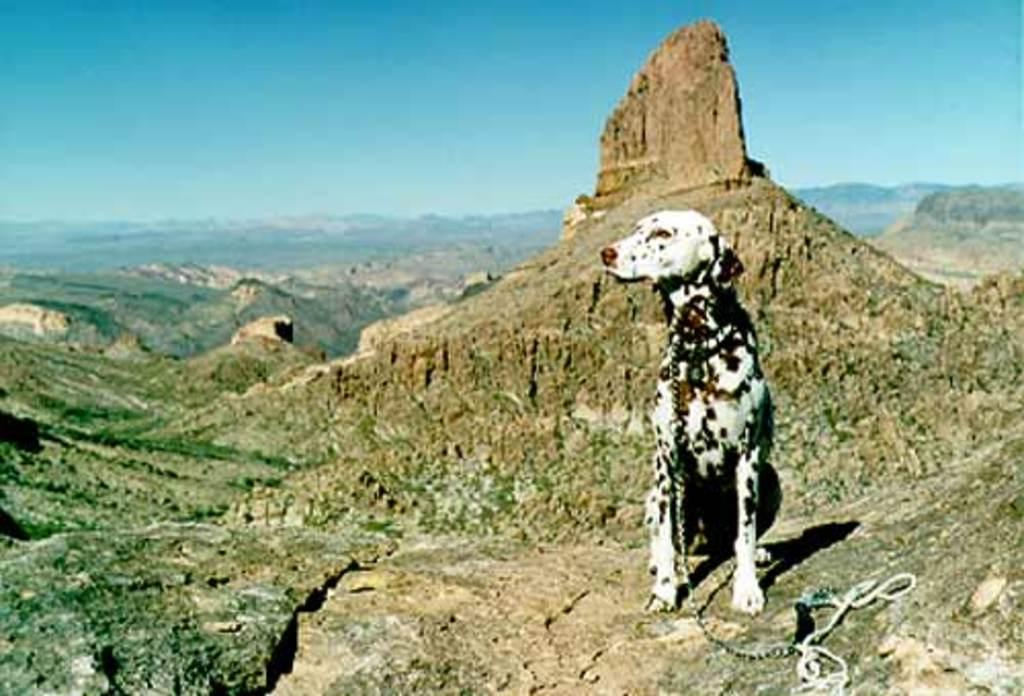What type of animal is present in the image? There is a dog in the image. How is the dog restrained in the image? The dog is attached to a chain. What can be seen in the distance in the image? There are hills visible in the background of the image. What type of bird is afraid of the dog in the image? There is no bird present in the image, so it is not possible to determine if any bird is afraid of the dog. 